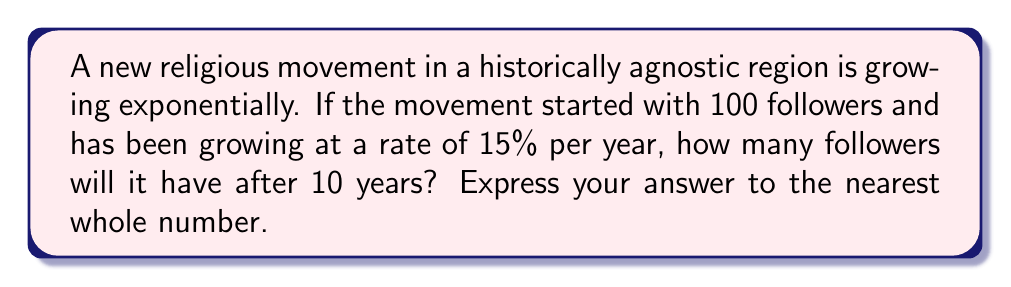Help me with this question. To solve this problem, we'll use the exponential growth function:

$$A = P(1 + r)^t$$

Where:
$A$ = Final amount
$P$ = Initial amount (principal)
$r$ = Growth rate (as a decimal)
$t$ = Time period

Given:
$P = 100$ (initial followers)
$r = 0.15$ (15% growth rate)
$t = 10$ years

Let's substitute these values into the equation:

$$A = 100(1 + 0.15)^{10}$$

Simplify:
$$A = 100(1.15)^{10}$$

Using a calculator or computing software:
$$A = 100 \times 4.0456$$
$$A = 404.56$$

Rounding to the nearest whole number:
$$A \approx 405$$

This growth pattern aligns with historical observations of how some religious movements have spread rapidly in regions previously characterized by religious indifference or agnosticism.
Answer: 405 followers 